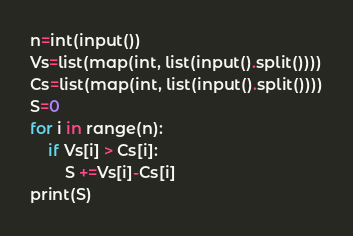Convert code to text. <code><loc_0><loc_0><loc_500><loc_500><_Python_>n=int(input())
Vs=list(map(int, list(input().split())))
Cs=list(map(int, list(input().split())))
S=0
for i in range(n):
    if Vs[i] > Cs[i]:
        S +=Vs[i]-Cs[i]
print(S)</code> 